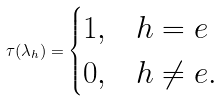<formula> <loc_0><loc_0><loc_500><loc_500>\tau ( \lambda _ { h } ) = \begin{cases} 1 , & h = e \\ 0 , & h \ne e . \end{cases}</formula> 